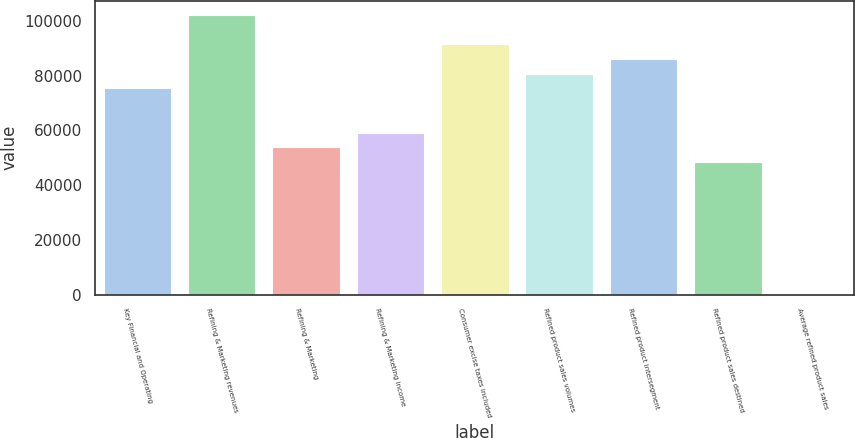Convert chart. <chart><loc_0><loc_0><loc_500><loc_500><bar_chart><fcel>Key Financial and Operating<fcel>Refining & Marketing revenues<fcel>Refining & Marketing<fcel>Refining & Marketing income<fcel>Consumer excise taxes included<fcel>Refined product sales volumes<fcel>Refined product intersegment<fcel>Refined product sales destined<fcel>Average refined product sales<nl><fcel>75343.2<fcel>102251<fcel>53817<fcel>59198.5<fcel>91487.8<fcel>80724.7<fcel>86106.3<fcel>48435.4<fcel>1.47<nl></chart> 